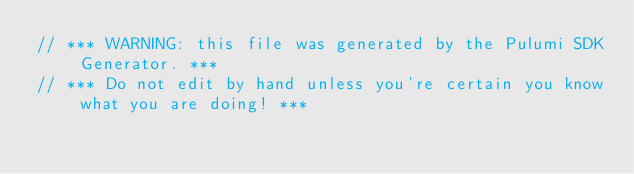<code> <loc_0><loc_0><loc_500><loc_500><_TypeScript_>// *** WARNING: this file was generated by the Pulumi SDK Generator. ***
// *** Do not edit by hand unless you're certain you know what you are doing! ***
</code> 